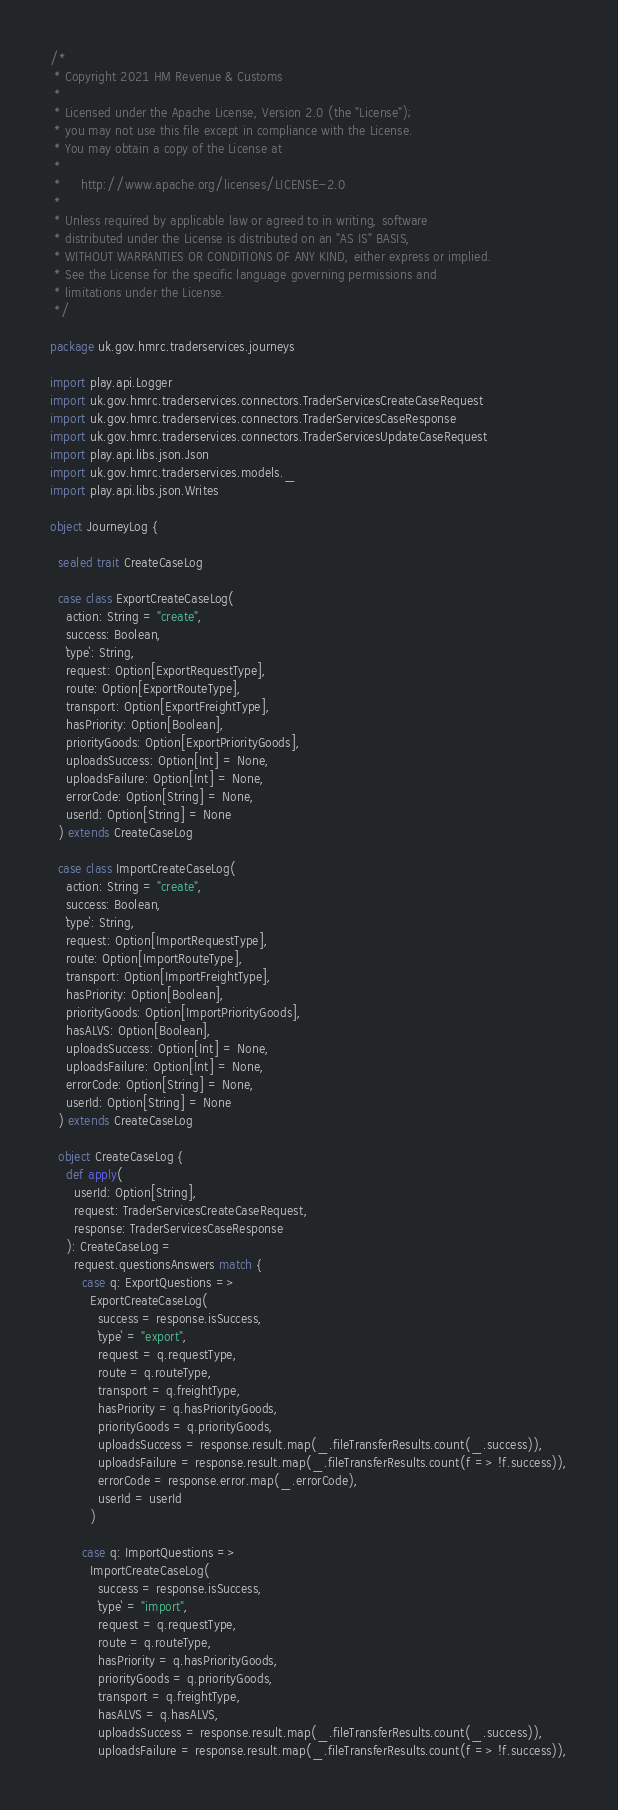Convert code to text. <code><loc_0><loc_0><loc_500><loc_500><_Scala_>/*
 * Copyright 2021 HM Revenue & Customs
 *
 * Licensed under the Apache License, Version 2.0 (the "License");
 * you may not use this file except in compliance with the License.
 * You may obtain a copy of the License at
 *
 *     http://www.apache.org/licenses/LICENSE-2.0
 *
 * Unless required by applicable law or agreed to in writing, software
 * distributed under the License is distributed on an "AS IS" BASIS,
 * WITHOUT WARRANTIES OR CONDITIONS OF ANY KIND, either express or implied.
 * See the License for the specific language governing permissions and
 * limitations under the License.
 */

package uk.gov.hmrc.traderservices.journeys

import play.api.Logger
import uk.gov.hmrc.traderservices.connectors.TraderServicesCreateCaseRequest
import uk.gov.hmrc.traderservices.connectors.TraderServicesCaseResponse
import uk.gov.hmrc.traderservices.connectors.TraderServicesUpdateCaseRequest
import play.api.libs.json.Json
import uk.gov.hmrc.traderservices.models._
import play.api.libs.json.Writes

object JourneyLog {

  sealed trait CreateCaseLog

  case class ExportCreateCaseLog(
    action: String = "create",
    success: Boolean,
    `type`: String,
    request: Option[ExportRequestType],
    route: Option[ExportRouteType],
    transport: Option[ExportFreightType],
    hasPriority: Option[Boolean],
    priorityGoods: Option[ExportPriorityGoods],
    uploadsSuccess: Option[Int] = None,
    uploadsFailure: Option[Int] = None,
    errorCode: Option[String] = None,
    userId: Option[String] = None
  ) extends CreateCaseLog

  case class ImportCreateCaseLog(
    action: String = "create",
    success: Boolean,
    `type`: String,
    request: Option[ImportRequestType],
    route: Option[ImportRouteType],
    transport: Option[ImportFreightType],
    hasPriority: Option[Boolean],
    priorityGoods: Option[ImportPriorityGoods],
    hasALVS: Option[Boolean],
    uploadsSuccess: Option[Int] = None,
    uploadsFailure: Option[Int] = None,
    errorCode: Option[String] = None,
    userId: Option[String] = None
  ) extends CreateCaseLog

  object CreateCaseLog {
    def apply(
      userId: Option[String],
      request: TraderServicesCreateCaseRequest,
      response: TraderServicesCaseResponse
    ): CreateCaseLog =
      request.questionsAnswers match {
        case q: ExportQuestions =>
          ExportCreateCaseLog(
            success = response.isSuccess,
            `type` = "export",
            request = q.requestType,
            route = q.routeType,
            transport = q.freightType,
            hasPriority = q.hasPriorityGoods,
            priorityGoods = q.priorityGoods,
            uploadsSuccess = response.result.map(_.fileTransferResults.count(_.success)),
            uploadsFailure = response.result.map(_.fileTransferResults.count(f => !f.success)),
            errorCode = response.error.map(_.errorCode),
            userId = userId
          )

        case q: ImportQuestions =>
          ImportCreateCaseLog(
            success = response.isSuccess,
            `type` = "import",
            request = q.requestType,
            route = q.routeType,
            hasPriority = q.hasPriorityGoods,
            priorityGoods = q.priorityGoods,
            transport = q.freightType,
            hasALVS = q.hasALVS,
            uploadsSuccess = response.result.map(_.fileTransferResults.count(_.success)),
            uploadsFailure = response.result.map(_.fileTransferResults.count(f => !f.success)),</code> 